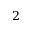<formula> <loc_0><loc_0><loc_500><loc_500>2</formula> 